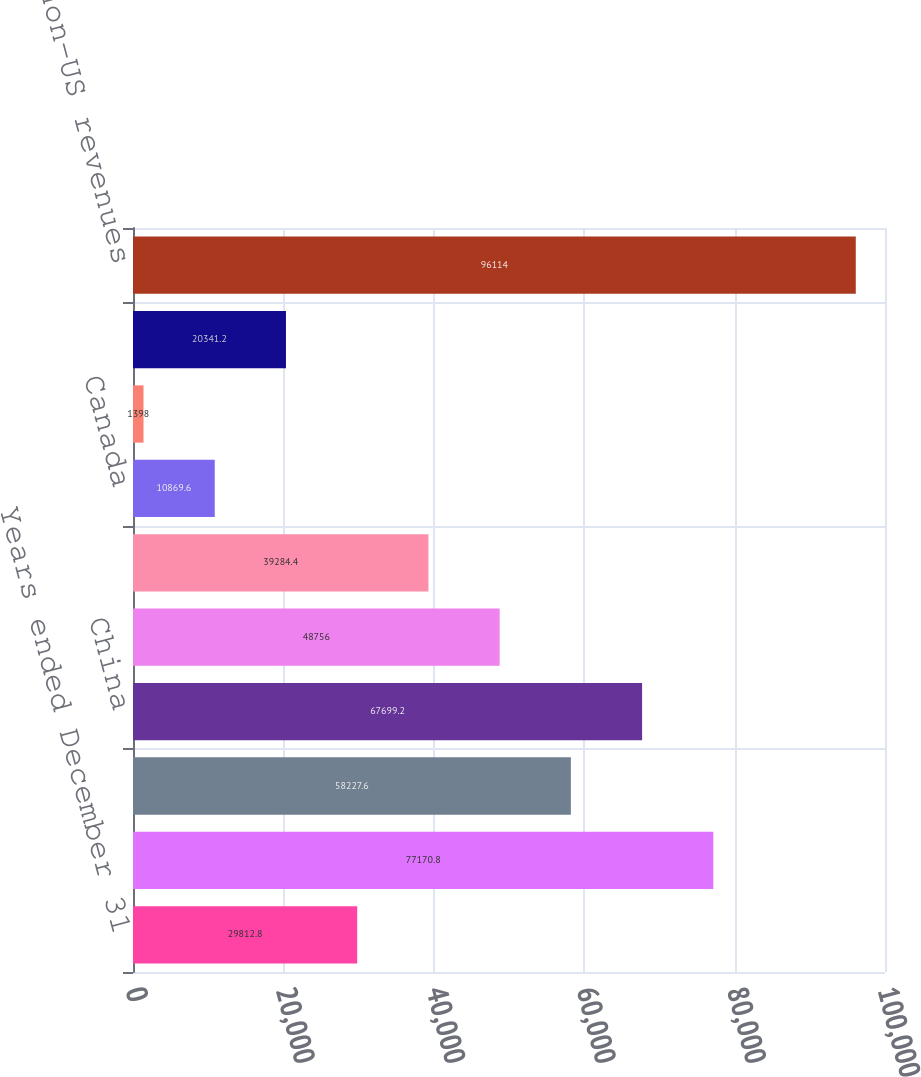Convert chart to OTSL. <chart><loc_0><loc_0><loc_500><loc_500><bar_chart><fcel>Years ended December 31<fcel>Asia other than China<fcel>Europe<fcel>China<fcel>Middle East<fcel>Oceania<fcel>Canada<fcel>Africa<fcel>Latin America Caribbean and<fcel>Total non-US revenues<nl><fcel>29812.8<fcel>77170.8<fcel>58227.6<fcel>67699.2<fcel>48756<fcel>39284.4<fcel>10869.6<fcel>1398<fcel>20341.2<fcel>96114<nl></chart> 